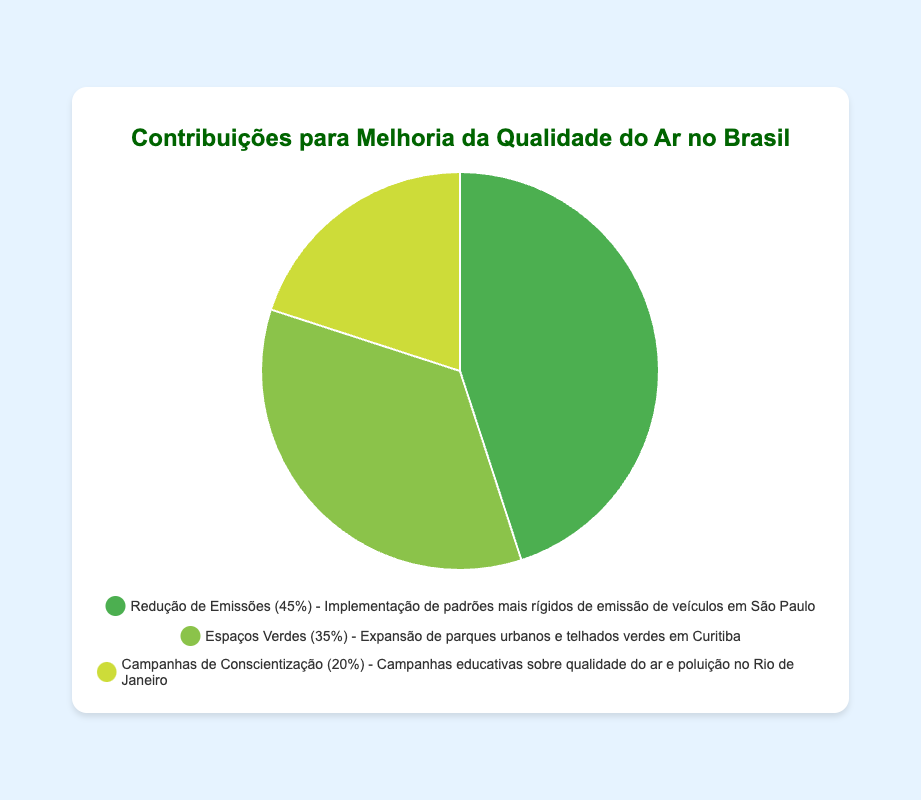What category has the highest contribution to air quality improvement? The category with the highest percentage on the pie chart is "Emission Reduction" at 45%.
Answer: Emission Reduction How much greater is the contribution of Emission Reduction compared to Green Spaces? Emission Reduction contributes 45% and Green Spaces contribute 35%. The difference is 45% - 35% = 10%.
Answer: 10% What percentage of contributions come from either Green Spaces or Public Awareness Campaigns? Green Spaces contribute 35% and Public Awareness Campaigns contribute 20%. The sum is 35% + 20% = 55%.
Answer: 55% If we add a new category called 'Technology Upgrades' with a 10% contribution, what will be the new percentage contribution of Emission Reduction? The current total percentage is 100%. Adding a new category with 10% bring the total to 110%. The new percentage contribution for Emission Reduction would be (45/110) * 100% = 40.91%.
Answer: 40.91% Which category contributes less than Public Awareness Campaigns? By looking at the pie chart, no category contributes less than Public Awareness Campaigns, which is the smallest at 20%.
Answer: None Among Emission Reduction and Green Spaces, which category has the closer percentage contribution to Public Awareness Campaigns? Emission Reduction is at 45% and Green Spaces are at 35%, while Public Awareness Campaigns are at 20%. The differences with Public Awareness Campaigns are 45% - 20% = 25% and 35% - 20% = 15%, respectively. Green Spaces have the closer percentage contribution.
Answer: Green Spaces What is the combined percentage contribution of the two largest categories? The two largest categories are Emission Reduction at 45% and Green Spaces at 35%. The sum is 45% + 35% = 80%.
Answer: 80% Which visual element represents the smallest contribution on the chart? The smallest segment of the pie chart represents Public Awareness Campaigns at 20%.
Answer: Public Awareness Campaigns How much more does Green Spaces contribute compared to Public Awareness Campaigns? Green Spaces contribute 35% and Public Awareness Campaigns contribute 20%. The difference is 35% - 20% = 15%.
Answer: 15% What color represents the category with the highest contribution? The segment representing Emission Reduction, which has the highest contribution of 45%, is colored green.
Answer: Green 